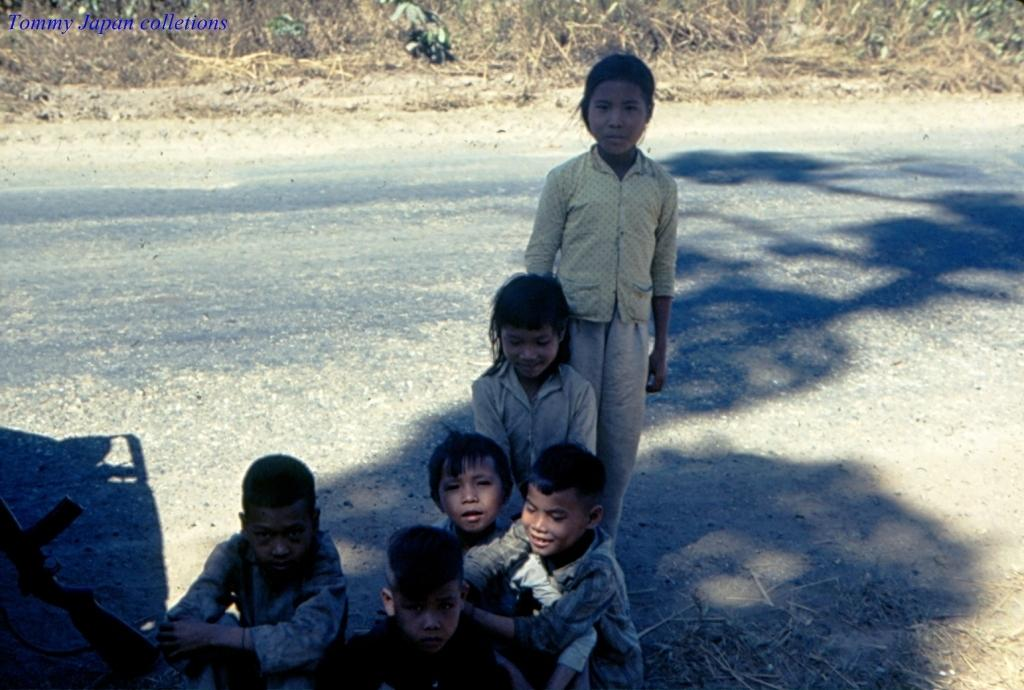What is the main feature of the image? There is a road in the image. What can be seen on either side of the road? There is dried grass on either side of the road. What are the children doing in the image? The children are sitting near the road, with one child standing near the sitting children. What object is present near the children? A gun is present near the children. What type of amusement can be seen in the image? There is no amusement present in the image; it features a road, dried grass, and children. Can you see a flame in the image? There is no flame present in the image. 